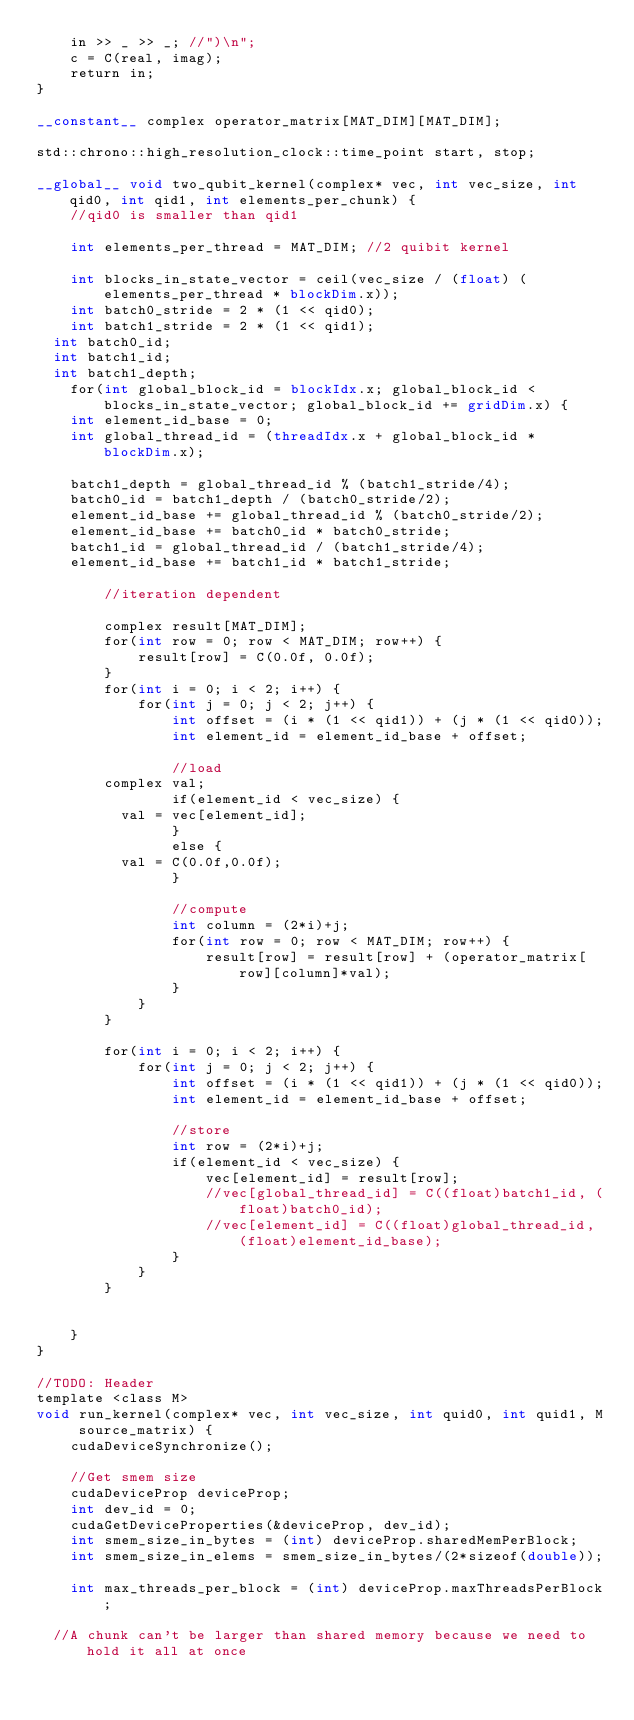Convert code to text. <code><loc_0><loc_0><loc_500><loc_500><_Cuda_>    in >> _ >> _; //")\n";
    c = C(real, imag);
    return in;
}

__constant__ complex operator_matrix[MAT_DIM][MAT_DIM];

std::chrono::high_resolution_clock::time_point start, stop;

__global__ void two_qubit_kernel(complex* vec, int vec_size, int qid0, int qid1, int elements_per_chunk) {
    //qid0 is smaller than qid1

    int elements_per_thread = MAT_DIM; //2 quibit kernel

    int blocks_in_state_vector = ceil(vec_size / (float) (elements_per_thread * blockDim.x));
    int batch0_stride = 2 * (1 << qid0);
    int batch1_stride = 2 * (1 << qid1);
	int batch0_id;
	int batch1_id;
	int batch1_depth;
    for(int global_block_id = blockIdx.x; global_block_id < blocks_in_state_vector; global_block_id += gridDim.x) {
		int element_id_base = 0;
		int global_thread_id = (threadIdx.x + global_block_id * blockDim.x);

		batch1_depth = global_thread_id % (batch1_stride/4);
		batch0_id = batch1_depth / (batch0_stride/2);
		element_id_base += global_thread_id % (batch0_stride/2);
		element_id_base += batch0_id * batch0_stride;
		batch1_id = global_thread_id / (batch1_stride/4);
		element_id_base += batch1_id * batch1_stride;

        //iteration dependent

        complex result[MAT_DIM];
        for(int row = 0; row < MAT_DIM; row++) {
            result[row] = C(0.0f, 0.0f);
        }
        for(int i = 0; i < 2; i++) {
            for(int j = 0; j < 2; j++) {
                int offset = (i * (1 << qid1)) + (j * (1 << qid0));
                int element_id = element_id_base + offset;

                //load
				complex val;
                if(element_id < vec_size) {
					val = vec[element_id];
                }
                else {
					val = C(0.0f,0.0f);
                }

                //compute
                int column = (2*i)+j;
                for(int row = 0; row < MAT_DIM; row++) {
                    result[row] = result[row] + (operator_matrix[row][column]*val);
                }
            }
        }

        for(int i = 0; i < 2; i++) {
            for(int j = 0; j < 2; j++) {
                int offset = (i * (1 << qid1)) + (j * (1 << qid0));
                int element_id = element_id_base + offset;

                //store
                int row = (2*i)+j;
                if(element_id < vec_size) {
                    vec[element_id] = result[row];
                    //vec[global_thread_id] = C((float)batch1_id, (float)batch0_id);
                    //vec[element_id] = C((float)global_thread_id, (float)element_id_base);
                }
            }
        }


    }
}

//TODO: Header
template <class M>
void run_kernel(complex* vec, int vec_size, int quid0, int quid1, M source_matrix) {
    cudaDeviceSynchronize();

    //Get smem size
    cudaDeviceProp deviceProp;
    int dev_id = 0;
    cudaGetDeviceProperties(&deviceProp, dev_id);
    int smem_size_in_bytes = (int) deviceProp.sharedMemPerBlock;
    int smem_size_in_elems = smem_size_in_bytes/(2*sizeof(double));

    int max_threads_per_block = (int) deviceProp.maxThreadsPerBlock;

	//A chunk can't be larger than shared memory because we need to hold it all at once</code> 